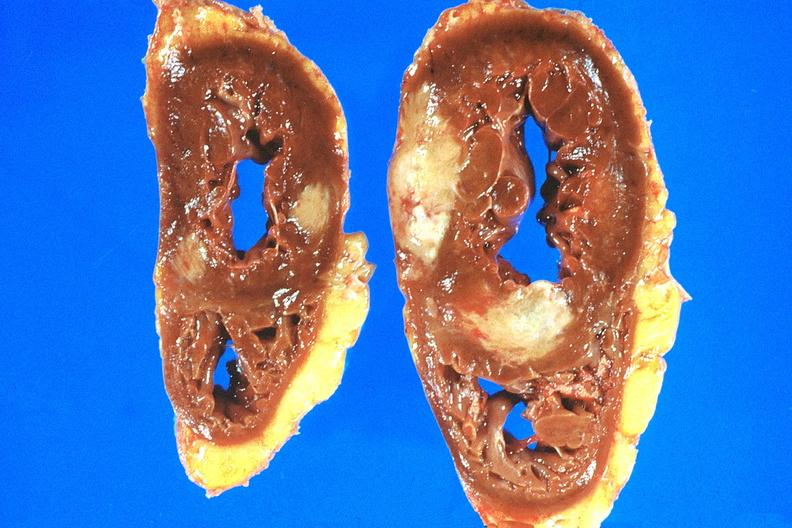s amyloidosis present?
Answer the question using a single word or phrase. No 